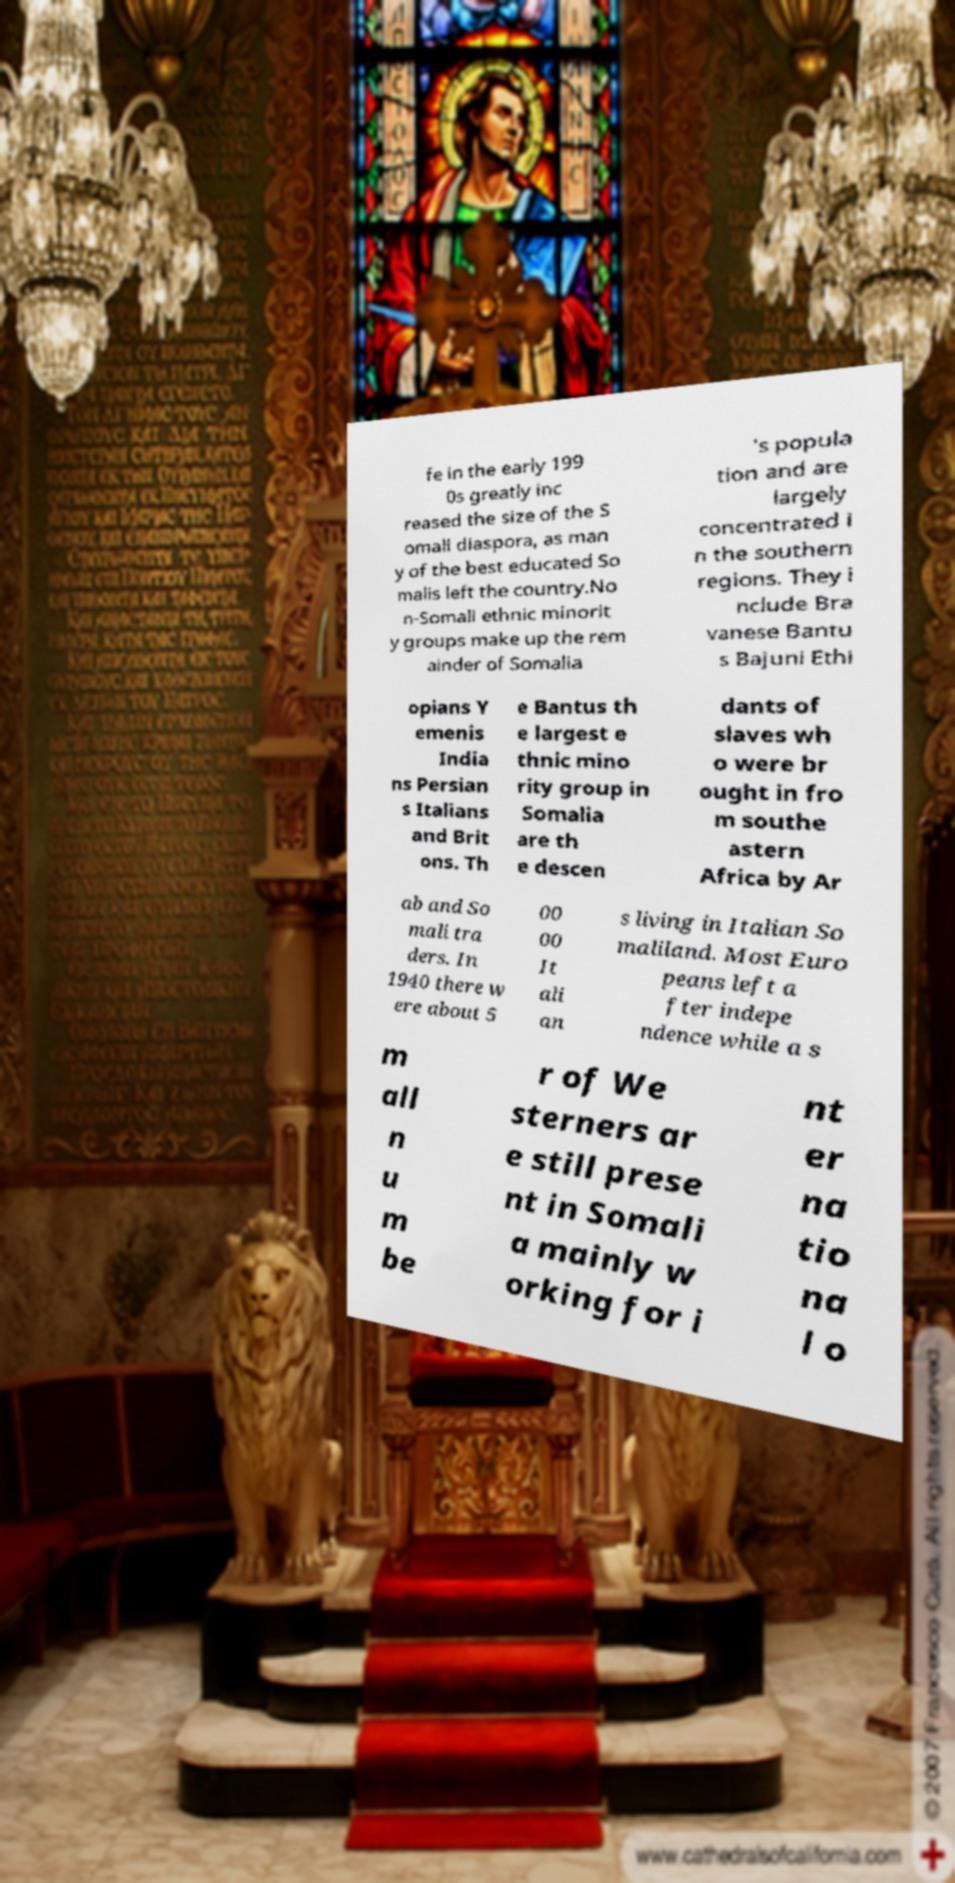For documentation purposes, I need the text within this image transcribed. Could you provide that? fe in the early 199 0s greatly inc reased the size of the S omali diaspora, as man y of the best educated So malis left the country.No n-Somali ethnic minorit y groups make up the rem ainder of Somalia 's popula tion and are largely concentrated i n the southern regions. They i nclude Bra vanese Bantu s Bajuni Ethi opians Y emenis India ns Persian s Italians and Brit ons. Th e Bantus th e largest e thnic mino rity group in Somalia are th e descen dants of slaves wh o were br ought in fro m southe astern Africa by Ar ab and So mali tra ders. In 1940 there w ere about 5 00 00 It ali an s living in Italian So maliland. Most Euro peans left a fter indepe ndence while a s m all n u m be r of We sterners ar e still prese nt in Somali a mainly w orking for i nt er na tio na l o 